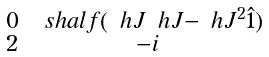Convert formula to latex. <formula><loc_0><loc_0><loc_500><loc_500>\begin{smallmatrix} \, 0 \, & \ s h a l f ( \ h J \ h J - \ h J ^ { 2 } \hat { 1 } ) \\ \, 2 \, & \, - i \, \\ \end{smallmatrix}</formula> 